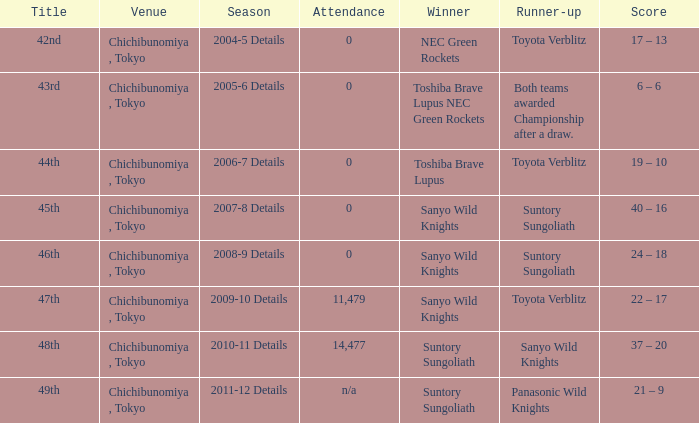What team was the winner when the runner-up shows both teams awarded championship after a draw.? Toshiba Brave Lupus NEC Green Rockets. Help me parse the entirety of this table. {'header': ['Title', 'Venue', 'Season', 'Attendance', 'Winner', 'Runner-up', 'Score'], 'rows': [['42nd', 'Chichibunomiya , Tokyo', '2004-5 Details', '0', 'NEC Green Rockets', 'Toyota Verblitz', '17 – 13'], ['43rd', 'Chichibunomiya , Tokyo', '2005-6 Details', '0', 'Toshiba Brave Lupus NEC Green Rockets', 'Both teams awarded Championship after a draw.', '6 – 6'], ['44th', 'Chichibunomiya , Tokyo', '2006-7 Details', '0', 'Toshiba Brave Lupus', 'Toyota Verblitz', '19 – 10'], ['45th', 'Chichibunomiya , Tokyo', '2007-8 Details', '0', 'Sanyo Wild Knights', 'Suntory Sungoliath', '40 – 16'], ['46th', 'Chichibunomiya , Tokyo', '2008-9 Details', '0', 'Sanyo Wild Knights', 'Suntory Sungoliath', '24 – 18'], ['47th', 'Chichibunomiya , Tokyo', '2009-10 Details', '11,479', 'Sanyo Wild Knights', 'Toyota Verblitz', '22 – 17'], ['48th', 'Chichibunomiya , Tokyo', '2010-11 Details', '14,477', 'Suntory Sungoliath', 'Sanyo Wild Knights', '37 – 20'], ['49th', 'Chichibunomiya , Tokyo', '2011-12 Details', 'n/a', 'Suntory Sungoliath', 'Panasonic Wild Knights', '21 – 9']]} 